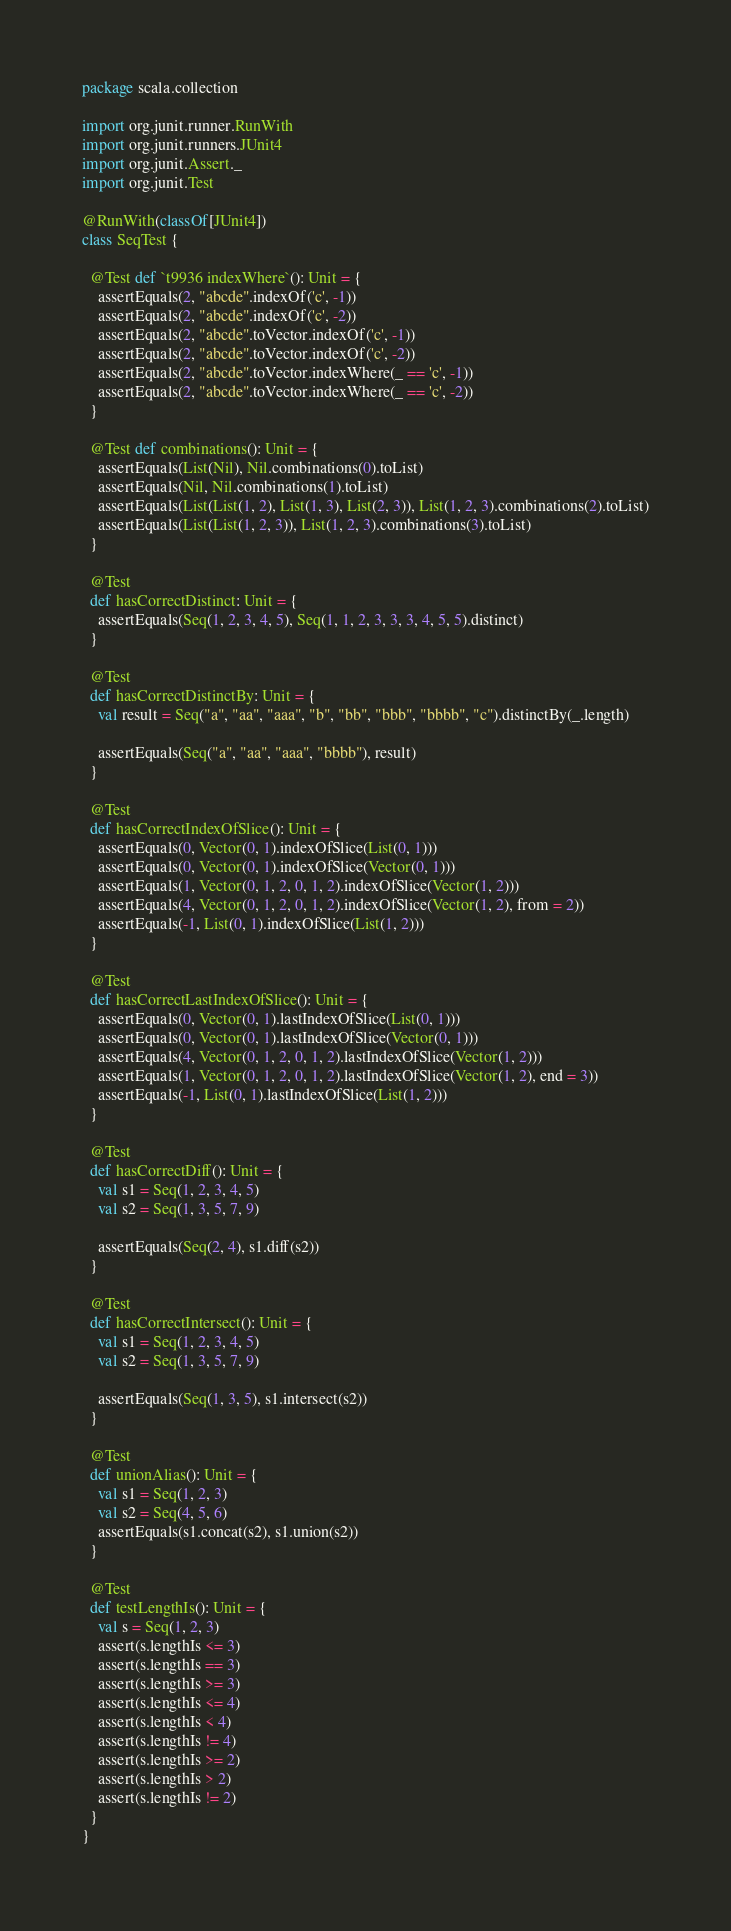<code> <loc_0><loc_0><loc_500><loc_500><_Scala_>package scala.collection

import org.junit.runner.RunWith
import org.junit.runners.JUnit4
import org.junit.Assert._
import org.junit.Test

@RunWith(classOf[JUnit4])
class SeqTest {

  @Test def `t9936 indexWhere`(): Unit = {
    assertEquals(2, "abcde".indexOf('c', -1))
    assertEquals(2, "abcde".indexOf('c', -2))
    assertEquals(2, "abcde".toVector.indexOf('c', -1))
    assertEquals(2, "abcde".toVector.indexOf('c', -2))
    assertEquals(2, "abcde".toVector.indexWhere(_ == 'c', -1))
    assertEquals(2, "abcde".toVector.indexWhere(_ == 'c', -2))
  }

  @Test def combinations(): Unit = {
    assertEquals(List(Nil), Nil.combinations(0).toList)
    assertEquals(Nil, Nil.combinations(1).toList)
    assertEquals(List(List(1, 2), List(1, 3), List(2, 3)), List(1, 2, 3).combinations(2).toList)
    assertEquals(List(List(1, 2, 3)), List(1, 2, 3).combinations(3).toList)
  }

  @Test
  def hasCorrectDistinct: Unit = {
    assertEquals(Seq(1, 2, 3, 4, 5), Seq(1, 1, 2, 3, 3, 3, 4, 5, 5).distinct)
  }

  @Test
  def hasCorrectDistinctBy: Unit = {
    val result = Seq("a", "aa", "aaa", "b", "bb", "bbb", "bbbb", "c").distinctBy(_.length)

    assertEquals(Seq("a", "aa", "aaa", "bbbb"), result)
  }

  @Test
  def hasCorrectIndexOfSlice(): Unit = {
    assertEquals(0, Vector(0, 1).indexOfSlice(List(0, 1)))
    assertEquals(0, Vector(0, 1).indexOfSlice(Vector(0, 1)))
    assertEquals(1, Vector(0, 1, 2, 0, 1, 2).indexOfSlice(Vector(1, 2)))
    assertEquals(4, Vector(0, 1, 2, 0, 1, 2).indexOfSlice(Vector(1, 2), from = 2))
    assertEquals(-1, List(0, 1).indexOfSlice(List(1, 2)))
  }

  @Test
  def hasCorrectLastIndexOfSlice(): Unit = {
    assertEquals(0, Vector(0, 1).lastIndexOfSlice(List(0, 1)))
    assertEquals(0, Vector(0, 1).lastIndexOfSlice(Vector(0, 1)))
    assertEquals(4, Vector(0, 1, 2, 0, 1, 2).lastIndexOfSlice(Vector(1, 2)))
    assertEquals(1, Vector(0, 1, 2, 0, 1, 2).lastIndexOfSlice(Vector(1, 2), end = 3))
    assertEquals(-1, List(0, 1).lastIndexOfSlice(List(1, 2)))
  }

  @Test
  def hasCorrectDiff(): Unit = {
    val s1 = Seq(1, 2, 3, 4, 5)
    val s2 = Seq(1, 3, 5, 7, 9)

    assertEquals(Seq(2, 4), s1.diff(s2))
  }

  @Test
  def hasCorrectIntersect(): Unit = {
    val s1 = Seq(1, 2, 3, 4, 5)
    val s2 = Seq(1, 3, 5, 7, 9)

    assertEquals(Seq(1, 3, 5), s1.intersect(s2))
  }

  @Test
  def unionAlias(): Unit = {
    val s1 = Seq(1, 2, 3)
    val s2 = Seq(4, 5, 6)
    assertEquals(s1.concat(s2), s1.union(s2))
  }

  @Test
  def testLengthIs(): Unit = {
    val s = Seq(1, 2, 3)
    assert(s.lengthIs <= 3)
    assert(s.lengthIs == 3)
    assert(s.lengthIs >= 3)
    assert(s.lengthIs <= 4)
    assert(s.lengthIs < 4)
    assert(s.lengthIs != 4)
    assert(s.lengthIs >= 2)
    assert(s.lengthIs > 2)
    assert(s.lengthIs != 2)
  }
}
</code> 